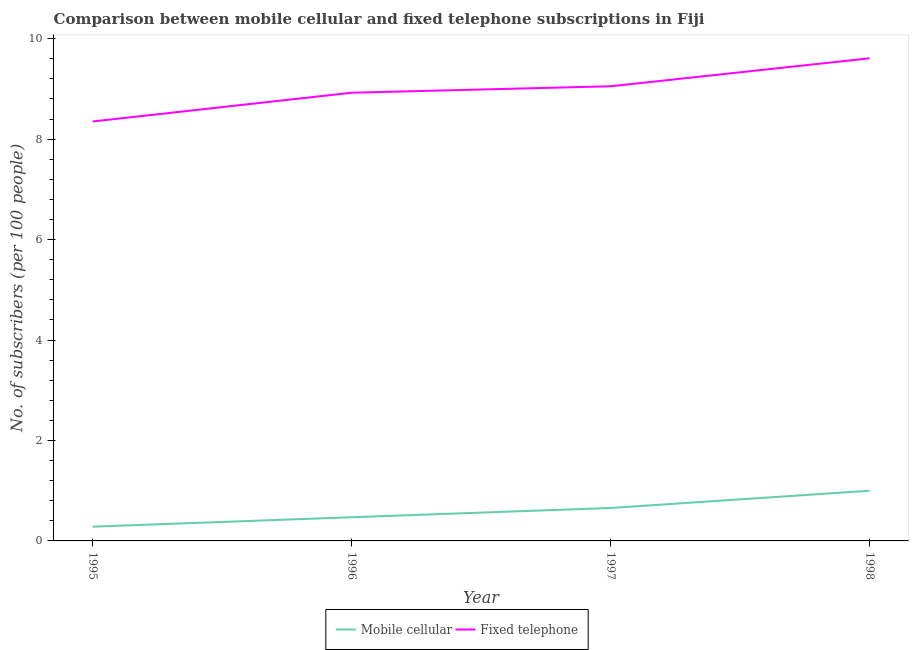How many different coloured lines are there?
Your response must be concise. 2. Does the line corresponding to number of mobile cellular subscribers intersect with the line corresponding to number of fixed telephone subscribers?
Make the answer very short. No. Is the number of lines equal to the number of legend labels?
Give a very brief answer. Yes. What is the number of mobile cellular subscribers in 1998?
Keep it short and to the point. 1. Across all years, what is the maximum number of fixed telephone subscribers?
Your answer should be compact. 9.61. Across all years, what is the minimum number of fixed telephone subscribers?
Offer a terse response. 8.35. What is the total number of mobile cellular subscribers in the graph?
Offer a very short reply. 2.41. What is the difference between the number of mobile cellular subscribers in 1995 and that in 1996?
Offer a terse response. -0.19. What is the difference between the number of fixed telephone subscribers in 1998 and the number of mobile cellular subscribers in 1996?
Ensure brevity in your answer.  9.14. What is the average number of fixed telephone subscribers per year?
Provide a succinct answer. 8.98. In the year 1996, what is the difference between the number of mobile cellular subscribers and number of fixed telephone subscribers?
Ensure brevity in your answer.  -8.45. In how many years, is the number of mobile cellular subscribers greater than 2.8?
Provide a succinct answer. 0. What is the ratio of the number of mobile cellular subscribers in 1996 to that in 1998?
Your answer should be compact. 0.47. What is the difference between the highest and the second highest number of mobile cellular subscribers?
Your response must be concise. 0.34. What is the difference between the highest and the lowest number of mobile cellular subscribers?
Offer a terse response. 0.72. Does the number of fixed telephone subscribers monotonically increase over the years?
Give a very brief answer. Yes. Is the number of mobile cellular subscribers strictly greater than the number of fixed telephone subscribers over the years?
Give a very brief answer. No. How many lines are there?
Make the answer very short. 2. How many years are there in the graph?
Give a very brief answer. 4. Are the values on the major ticks of Y-axis written in scientific E-notation?
Ensure brevity in your answer.  No. Does the graph contain any zero values?
Your response must be concise. No. Does the graph contain grids?
Keep it short and to the point. No. How many legend labels are there?
Keep it short and to the point. 2. What is the title of the graph?
Your answer should be compact. Comparison between mobile cellular and fixed telephone subscriptions in Fiji. Does "Foreign liabilities" appear as one of the legend labels in the graph?
Ensure brevity in your answer.  No. What is the label or title of the Y-axis?
Give a very brief answer. No. of subscribers (per 100 people). What is the No. of subscribers (per 100 people) of Mobile cellular in 1995?
Make the answer very short. 0.28. What is the No. of subscribers (per 100 people) in Fixed telephone in 1995?
Provide a short and direct response. 8.35. What is the No. of subscribers (per 100 people) in Mobile cellular in 1996?
Give a very brief answer. 0.47. What is the No. of subscribers (per 100 people) in Fixed telephone in 1996?
Keep it short and to the point. 8.92. What is the No. of subscribers (per 100 people) in Mobile cellular in 1997?
Offer a very short reply. 0.66. What is the No. of subscribers (per 100 people) in Fixed telephone in 1997?
Your answer should be compact. 9.05. What is the No. of subscribers (per 100 people) of Mobile cellular in 1998?
Keep it short and to the point. 1. What is the No. of subscribers (per 100 people) of Fixed telephone in 1998?
Give a very brief answer. 9.61. Across all years, what is the maximum No. of subscribers (per 100 people) in Mobile cellular?
Your answer should be compact. 1. Across all years, what is the maximum No. of subscribers (per 100 people) of Fixed telephone?
Give a very brief answer. 9.61. Across all years, what is the minimum No. of subscribers (per 100 people) of Mobile cellular?
Your answer should be compact. 0.28. Across all years, what is the minimum No. of subscribers (per 100 people) of Fixed telephone?
Offer a terse response. 8.35. What is the total No. of subscribers (per 100 people) of Mobile cellular in the graph?
Keep it short and to the point. 2.41. What is the total No. of subscribers (per 100 people) in Fixed telephone in the graph?
Offer a very short reply. 35.94. What is the difference between the No. of subscribers (per 100 people) in Mobile cellular in 1995 and that in 1996?
Your answer should be compact. -0.19. What is the difference between the No. of subscribers (per 100 people) in Fixed telephone in 1995 and that in 1996?
Keep it short and to the point. -0.57. What is the difference between the No. of subscribers (per 100 people) in Mobile cellular in 1995 and that in 1997?
Provide a short and direct response. -0.37. What is the difference between the No. of subscribers (per 100 people) of Fixed telephone in 1995 and that in 1997?
Your response must be concise. -0.7. What is the difference between the No. of subscribers (per 100 people) in Mobile cellular in 1995 and that in 1998?
Provide a succinct answer. -0.72. What is the difference between the No. of subscribers (per 100 people) in Fixed telephone in 1995 and that in 1998?
Ensure brevity in your answer.  -1.26. What is the difference between the No. of subscribers (per 100 people) in Mobile cellular in 1996 and that in 1997?
Offer a very short reply. -0.18. What is the difference between the No. of subscribers (per 100 people) of Fixed telephone in 1996 and that in 1997?
Offer a very short reply. -0.13. What is the difference between the No. of subscribers (per 100 people) of Mobile cellular in 1996 and that in 1998?
Keep it short and to the point. -0.53. What is the difference between the No. of subscribers (per 100 people) in Fixed telephone in 1996 and that in 1998?
Give a very brief answer. -0.69. What is the difference between the No. of subscribers (per 100 people) of Mobile cellular in 1997 and that in 1998?
Offer a terse response. -0.34. What is the difference between the No. of subscribers (per 100 people) of Fixed telephone in 1997 and that in 1998?
Offer a terse response. -0.56. What is the difference between the No. of subscribers (per 100 people) in Mobile cellular in 1995 and the No. of subscribers (per 100 people) in Fixed telephone in 1996?
Provide a succinct answer. -8.64. What is the difference between the No. of subscribers (per 100 people) in Mobile cellular in 1995 and the No. of subscribers (per 100 people) in Fixed telephone in 1997?
Provide a short and direct response. -8.77. What is the difference between the No. of subscribers (per 100 people) of Mobile cellular in 1995 and the No. of subscribers (per 100 people) of Fixed telephone in 1998?
Keep it short and to the point. -9.33. What is the difference between the No. of subscribers (per 100 people) of Mobile cellular in 1996 and the No. of subscribers (per 100 people) of Fixed telephone in 1997?
Offer a terse response. -8.58. What is the difference between the No. of subscribers (per 100 people) of Mobile cellular in 1996 and the No. of subscribers (per 100 people) of Fixed telephone in 1998?
Provide a short and direct response. -9.14. What is the difference between the No. of subscribers (per 100 people) in Mobile cellular in 1997 and the No. of subscribers (per 100 people) in Fixed telephone in 1998?
Your answer should be compact. -8.95. What is the average No. of subscribers (per 100 people) of Mobile cellular per year?
Make the answer very short. 0.6. What is the average No. of subscribers (per 100 people) in Fixed telephone per year?
Keep it short and to the point. 8.98. In the year 1995, what is the difference between the No. of subscribers (per 100 people) in Mobile cellular and No. of subscribers (per 100 people) in Fixed telephone?
Your answer should be very brief. -8.07. In the year 1996, what is the difference between the No. of subscribers (per 100 people) in Mobile cellular and No. of subscribers (per 100 people) in Fixed telephone?
Your answer should be very brief. -8.45. In the year 1997, what is the difference between the No. of subscribers (per 100 people) of Mobile cellular and No. of subscribers (per 100 people) of Fixed telephone?
Give a very brief answer. -8.4. In the year 1998, what is the difference between the No. of subscribers (per 100 people) of Mobile cellular and No. of subscribers (per 100 people) of Fixed telephone?
Ensure brevity in your answer.  -8.61. What is the ratio of the No. of subscribers (per 100 people) of Mobile cellular in 1995 to that in 1996?
Your answer should be compact. 0.6. What is the ratio of the No. of subscribers (per 100 people) of Fixed telephone in 1995 to that in 1996?
Make the answer very short. 0.94. What is the ratio of the No. of subscribers (per 100 people) of Mobile cellular in 1995 to that in 1997?
Your answer should be compact. 0.43. What is the ratio of the No. of subscribers (per 100 people) in Fixed telephone in 1995 to that in 1997?
Ensure brevity in your answer.  0.92. What is the ratio of the No. of subscribers (per 100 people) of Mobile cellular in 1995 to that in 1998?
Your answer should be compact. 0.28. What is the ratio of the No. of subscribers (per 100 people) of Fixed telephone in 1995 to that in 1998?
Give a very brief answer. 0.87. What is the ratio of the No. of subscribers (per 100 people) of Mobile cellular in 1996 to that in 1997?
Offer a very short reply. 0.72. What is the ratio of the No. of subscribers (per 100 people) of Fixed telephone in 1996 to that in 1997?
Your answer should be compact. 0.99. What is the ratio of the No. of subscribers (per 100 people) of Mobile cellular in 1996 to that in 1998?
Offer a terse response. 0.47. What is the ratio of the No. of subscribers (per 100 people) of Mobile cellular in 1997 to that in 1998?
Keep it short and to the point. 0.66. What is the ratio of the No. of subscribers (per 100 people) of Fixed telephone in 1997 to that in 1998?
Offer a very short reply. 0.94. What is the difference between the highest and the second highest No. of subscribers (per 100 people) of Mobile cellular?
Offer a terse response. 0.34. What is the difference between the highest and the second highest No. of subscribers (per 100 people) of Fixed telephone?
Your answer should be compact. 0.56. What is the difference between the highest and the lowest No. of subscribers (per 100 people) in Mobile cellular?
Keep it short and to the point. 0.72. What is the difference between the highest and the lowest No. of subscribers (per 100 people) of Fixed telephone?
Give a very brief answer. 1.26. 